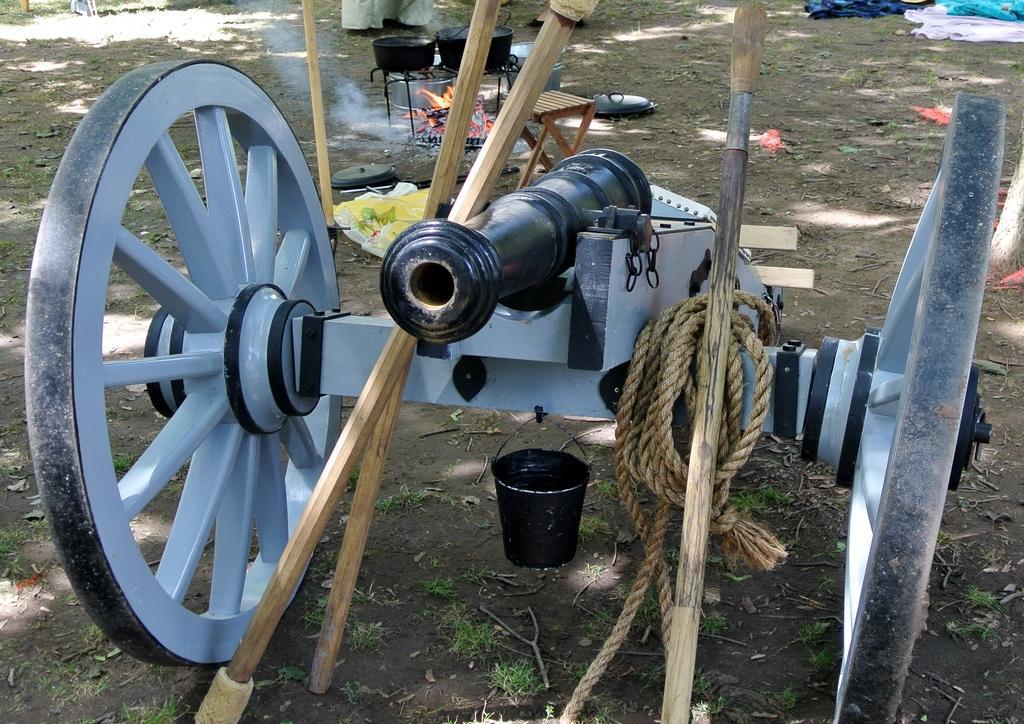Can you describe this image briefly? In this image there is a canon, there are sticks, there is a rope, there is a bucket, there is water, there is are objects on the ground, there are clothes towards the top of the image, there is grass on the ground. 